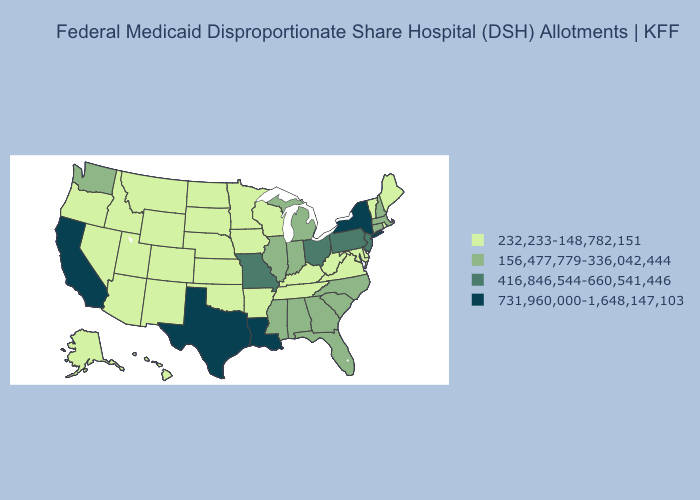Does Arkansas have the highest value in the South?
Give a very brief answer. No. Does the map have missing data?
Short answer required. No. Name the states that have a value in the range 731,960,000-1,648,147,103?
Be succinct. California, Louisiana, New York, Texas. How many symbols are there in the legend?
Short answer required. 4. What is the value of Michigan?
Write a very short answer. 156,477,779-336,042,444. What is the highest value in states that border Idaho?
Short answer required. 156,477,779-336,042,444. Name the states that have a value in the range 731,960,000-1,648,147,103?
Write a very short answer. California, Louisiana, New York, Texas. What is the value of Tennessee?
Short answer required. 232,233-148,782,151. Among the states that border Virginia , does North Carolina have the lowest value?
Concise answer only. No. Name the states that have a value in the range 416,846,544-660,541,446?
Be succinct. Missouri, New Jersey, Ohio, Pennsylvania. Name the states that have a value in the range 416,846,544-660,541,446?
Short answer required. Missouri, New Jersey, Ohio, Pennsylvania. Which states have the highest value in the USA?
Short answer required. California, Louisiana, New York, Texas. Among the states that border Kansas , does Missouri have the lowest value?
Short answer required. No. Name the states that have a value in the range 232,233-148,782,151?
Give a very brief answer. Alaska, Arizona, Arkansas, Colorado, Delaware, Hawaii, Idaho, Iowa, Kansas, Kentucky, Maine, Maryland, Minnesota, Montana, Nebraska, Nevada, New Mexico, North Dakota, Oklahoma, Oregon, Rhode Island, South Dakota, Tennessee, Utah, Vermont, Virginia, West Virginia, Wisconsin, Wyoming. Is the legend a continuous bar?
Keep it brief. No. 